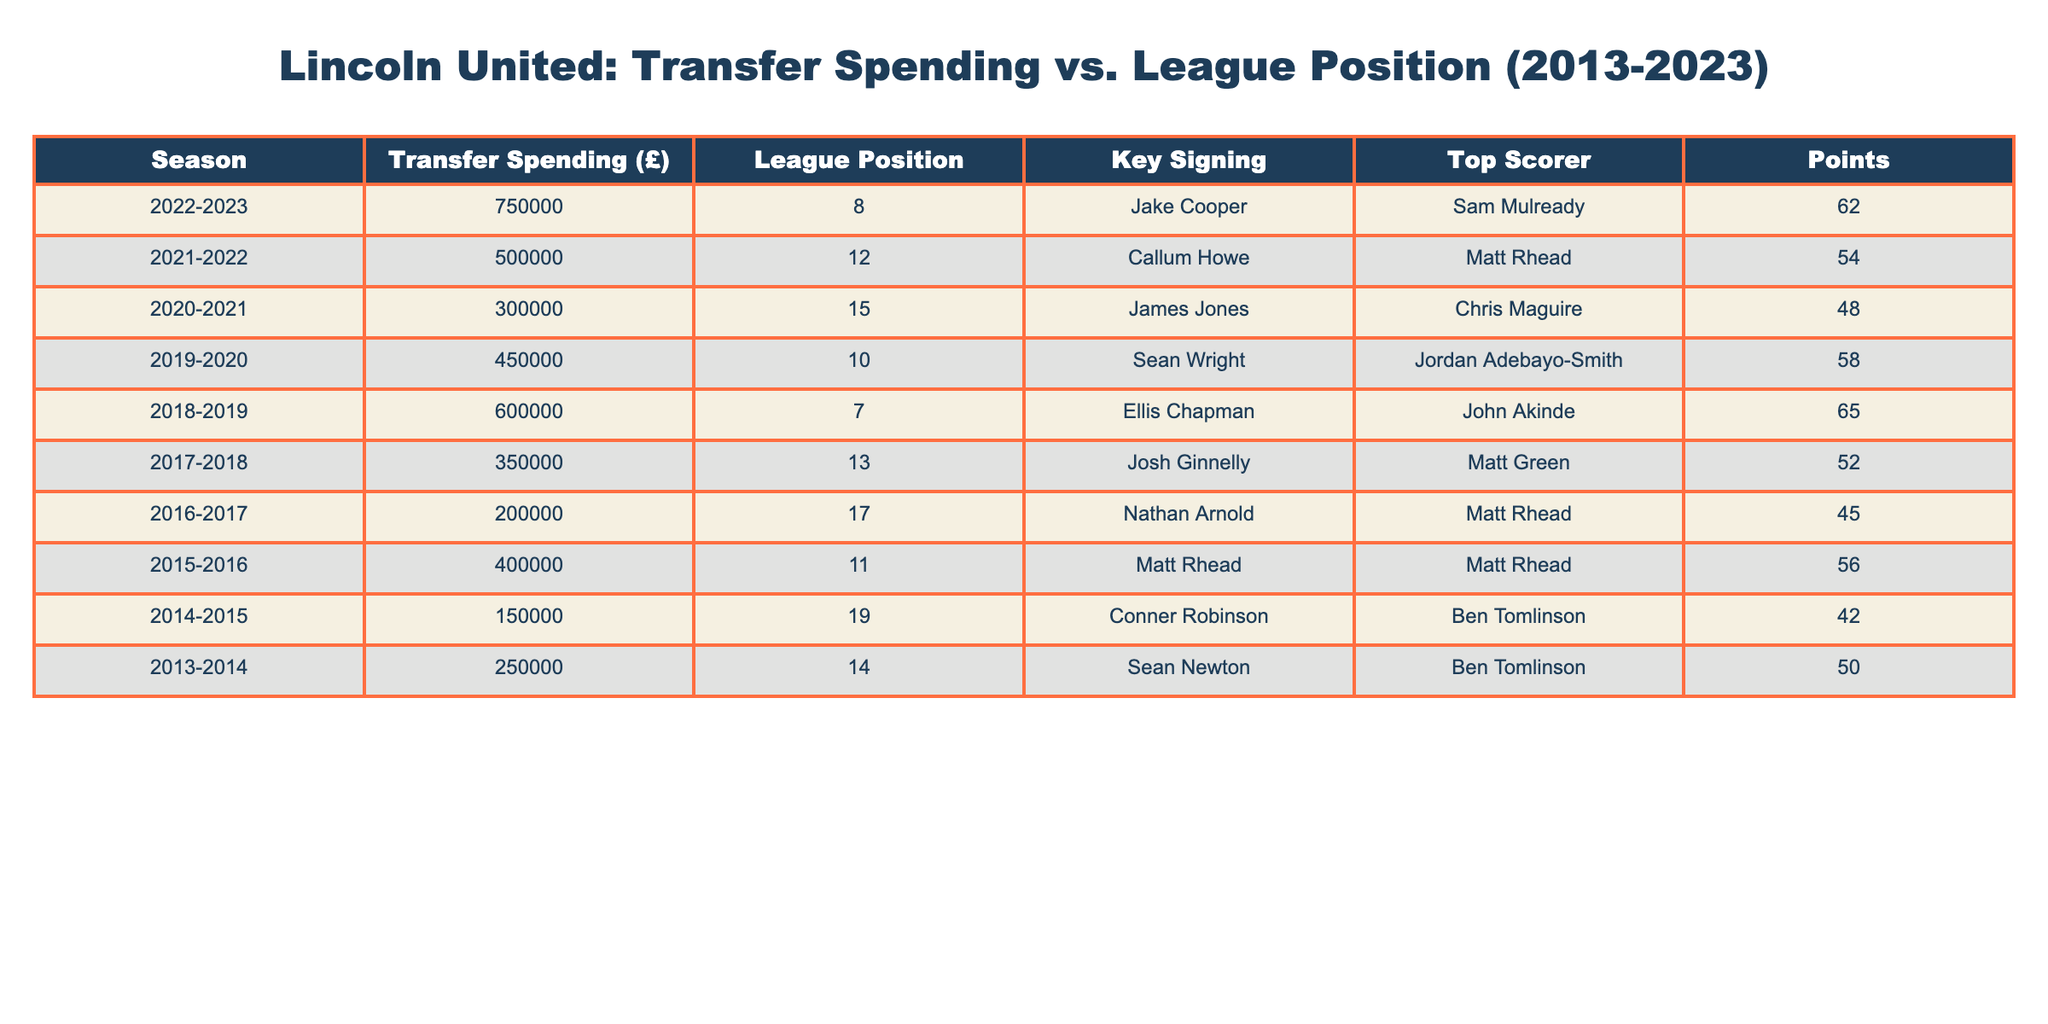What was Lincoln United's highest transfer spending in the past 10 years? By checking the 'Transfer Spending (£)' column, the highest value noted is for the season 2022-2023 with £750,000.
Answer: £750,000 What league position did Lincoln United achieve in the 2018-2019 season? Looking at the 'League Position' column for the 2018-2019 season, it shows a position of 7.
Answer: 7 How much did Lincoln United spend on transfers during the 2016-2017 season? The 'Transfer Spending (£)' for the 2016-2017 season is listed as £200,000.
Answer: £200,000 Is it true that Lincoln United had a league position of 15 or worse in consecutive years between 2019-2021? In the 2019-2020 season, the position was 10; in the 2020-2021 season, it was 15; however, they did not have worse than 15 in consecutive years, since 2019-2020 was better.
Answer: No What was Lincoln United's average transfer spending over the 10 seasons? The total transfer spending over the 10 seasons is £750,000 + £500,000 + £300,000 + £450,000 + £600,000 + £350,000 + £200,000 + £400,000 + £150,000 + £250,000 = £3,600,000. Dividing by 10 seasons gives an average of £360,000.
Answer: £360,000 Which season had the most points earned, and how many points did they earn? The best points total is from the 2018-2019 season, where Lincoln United earned 65 points, the highest in the table.
Answer: 65 points What was the lowest league position achieved by Lincoln United in this data? Referring to the 'League Position' column, the lowest position noted is 19 for the 2014-2015 season.
Answer: 19 In which season did Lincoln United have the best-performing top scorer based on the table? The top scorer for the 2018-2019 season was John Akinde, which coincides with the highest points earned (65), indicating a strong performance that season.
Answer: 2018-2019 How many seasons had Lincoln United spending over £500,000? From the data, the seasons with transfer spending over £500,000 are 2022-2023 (£750,000), 2018-2019 (£600,000), and 2019-2020 (£450,000). Therefore, there are 2 such seasons.
Answer: 2 